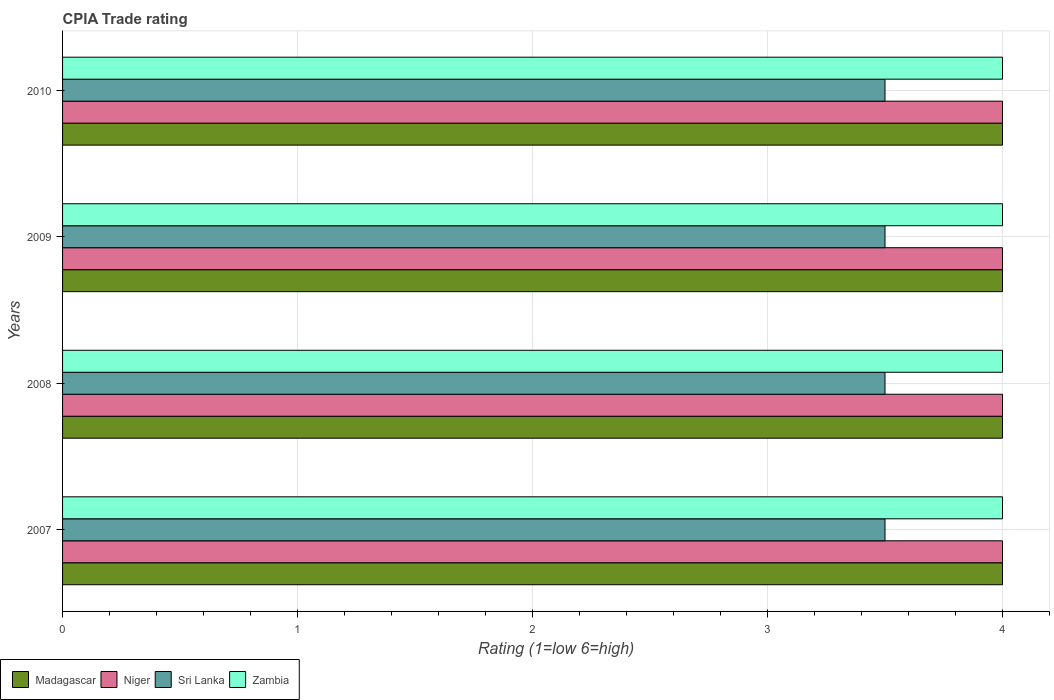What is the CPIA rating in Niger in 2008?
Provide a succinct answer. 4. Across all years, what is the maximum CPIA rating in Sri Lanka?
Make the answer very short. 3.5. In which year was the CPIA rating in Madagascar maximum?
Your response must be concise. 2007. What is the total CPIA rating in Zambia in the graph?
Ensure brevity in your answer.  16. In the year 2010, what is the difference between the CPIA rating in Niger and CPIA rating in Sri Lanka?
Make the answer very short. 0.5. What is the ratio of the CPIA rating in Madagascar in 2008 to that in 2010?
Provide a succinct answer. 1. Is the difference between the CPIA rating in Niger in 2008 and 2009 greater than the difference between the CPIA rating in Sri Lanka in 2008 and 2009?
Give a very brief answer. No. What is the difference between the highest and the second highest CPIA rating in Zambia?
Give a very brief answer. 0. What is the difference between the highest and the lowest CPIA rating in Madagascar?
Give a very brief answer. 0. What does the 2nd bar from the top in 2008 represents?
Provide a succinct answer. Sri Lanka. What does the 1st bar from the bottom in 2008 represents?
Your answer should be very brief. Madagascar. How many bars are there?
Your answer should be compact. 16. How many years are there in the graph?
Keep it short and to the point. 4. Does the graph contain any zero values?
Give a very brief answer. No. Where does the legend appear in the graph?
Make the answer very short. Bottom left. How many legend labels are there?
Your response must be concise. 4. How are the legend labels stacked?
Offer a terse response. Horizontal. What is the title of the graph?
Keep it short and to the point. CPIA Trade rating. Does "Cyprus" appear as one of the legend labels in the graph?
Provide a short and direct response. No. What is the label or title of the X-axis?
Keep it short and to the point. Rating (1=low 6=high). What is the Rating (1=low 6=high) of Niger in 2007?
Your answer should be compact. 4. What is the Rating (1=low 6=high) in Sri Lanka in 2007?
Provide a succinct answer. 3.5. What is the Rating (1=low 6=high) of Niger in 2008?
Your answer should be very brief. 4. What is the Rating (1=low 6=high) of Madagascar in 2009?
Keep it short and to the point. 4. What is the Rating (1=low 6=high) in Niger in 2009?
Make the answer very short. 4. What is the Rating (1=low 6=high) in Sri Lanka in 2009?
Give a very brief answer. 3.5. What is the Rating (1=low 6=high) in Zambia in 2009?
Ensure brevity in your answer.  4. What is the Rating (1=low 6=high) of Sri Lanka in 2010?
Make the answer very short. 3.5. Across all years, what is the maximum Rating (1=low 6=high) in Madagascar?
Offer a very short reply. 4. Across all years, what is the maximum Rating (1=low 6=high) of Niger?
Your answer should be compact. 4. Across all years, what is the minimum Rating (1=low 6=high) in Madagascar?
Make the answer very short. 4. Across all years, what is the minimum Rating (1=low 6=high) in Sri Lanka?
Give a very brief answer. 3.5. Across all years, what is the minimum Rating (1=low 6=high) in Zambia?
Your answer should be compact. 4. What is the total Rating (1=low 6=high) in Niger in the graph?
Provide a short and direct response. 16. What is the total Rating (1=low 6=high) of Zambia in the graph?
Keep it short and to the point. 16. What is the difference between the Rating (1=low 6=high) in Sri Lanka in 2007 and that in 2008?
Provide a short and direct response. 0. What is the difference between the Rating (1=low 6=high) of Zambia in 2007 and that in 2008?
Offer a very short reply. 0. What is the difference between the Rating (1=low 6=high) in Madagascar in 2007 and that in 2009?
Give a very brief answer. 0. What is the difference between the Rating (1=low 6=high) in Sri Lanka in 2007 and that in 2009?
Offer a very short reply. 0. What is the difference between the Rating (1=low 6=high) in Zambia in 2007 and that in 2009?
Offer a terse response. 0. What is the difference between the Rating (1=low 6=high) in Niger in 2007 and that in 2010?
Your response must be concise. 0. What is the difference between the Rating (1=low 6=high) in Madagascar in 2008 and that in 2009?
Provide a short and direct response. 0. What is the difference between the Rating (1=low 6=high) in Niger in 2008 and that in 2009?
Offer a very short reply. 0. What is the difference between the Rating (1=low 6=high) of Madagascar in 2008 and that in 2010?
Your answer should be very brief. 0. What is the difference between the Rating (1=low 6=high) of Zambia in 2008 and that in 2010?
Provide a short and direct response. 0. What is the difference between the Rating (1=low 6=high) in Madagascar in 2009 and that in 2010?
Offer a very short reply. 0. What is the difference between the Rating (1=low 6=high) in Niger in 2009 and that in 2010?
Your response must be concise. 0. What is the difference between the Rating (1=low 6=high) of Sri Lanka in 2009 and that in 2010?
Give a very brief answer. 0. What is the difference between the Rating (1=low 6=high) in Madagascar in 2007 and the Rating (1=low 6=high) in Sri Lanka in 2008?
Offer a terse response. 0.5. What is the difference between the Rating (1=low 6=high) in Niger in 2007 and the Rating (1=low 6=high) in Sri Lanka in 2008?
Your response must be concise. 0.5. What is the difference between the Rating (1=low 6=high) in Madagascar in 2007 and the Rating (1=low 6=high) in Sri Lanka in 2009?
Provide a short and direct response. 0.5. What is the difference between the Rating (1=low 6=high) of Madagascar in 2007 and the Rating (1=low 6=high) of Zambia in 2009?
Your answer should be very brief. 0. What is the difference between the Rating (1=low 6=high) in Niger in 2007 and the Rating (1=low 6=high) in Zambia in 2009?
Keep it short and to the point. 0. What is the difference between the Rating (1=low 6=high) in Madagascar in 2007 and the Rating (1=low 6=high) in Zambia in 2010?
Make the answer very short. 0. What is the difference between the Rating (1=low 6=high) in Sri Lanka in 2007 and the Rating (1=low 6=high) in Zambia in 2010?
Keep it short and to the point. -0.5. What is the difference between the Rating (1=low 6=high) in Madagascar in 2008 and the Rating (1=low 6=high) in Niger in 2009?
Keep it short and to the point. 0. What is the difference between the Rating (1=low 6=high) in Madagascar in 2008 and the Rating (1=low 6=high) in Niger in 2010?
Ensure brevity in your answer.  0. What is the difference between the Rating (1=low 6=high) of Niger in 2008 and the Rating (1=low 6=high) of Sri Lanka in 2010?
Your answer should be compact. 0.5. What is the difference between the Rating (1=low 6=high) in Niger in 2008 and the Rating (1=low 6=high) in Zambia in 2010?
Provide a succinct answer. 0. What is the difference between the Rating (1=low 6=high) of Sri Lanka in 2008 and the Rating (1=low 6=high) of Zambia in 2010?
Give a very brief answer. -0.5. What is the difference between the Rating (1=low 6=high) of Madagascar in 2009 and the Rating (1=low 6=high) of Sri Lanka in 2010?
Your response must be concise. 0.5. What is the difference between the Rating (1=low 6=high) of Madagascar in 2009 and the Rating (1=low 6=high) of Zambia in 2010?
Offer a very short reply. 0. What is the difference between the Rating (1=low 6=high) in Sri Lanka in 2009 and the Rating (1=low 6=high) in Zambia in 2010?
Your response must be concise. -0.5. What is the average Rating (1=low 6=high) in Madagascar per year?
Provide a short and direct response. 4. In the year 2007, what is the difference between the Rating (1=low 6=high) in Madagascar and Rating (1=low 6=high) in Niger?
Offer a very short reply. 0. In the year 2007, what is the difference between the Rating (1=low 6=high) in Madagascar and Rating (1=low 6=high) in Sri Lanka?
Keep it short and to the point. 0.5. In the year 2007, what is the difference between the Rating (1=low 6=high) in Niger and Rating (1=low 6=high) in Zambia?
Keep it short and to the point. 0. In the year 2008, what is the difference between the Rating (1=low 6=high) in Madagascar and Rating (1=low 6=high) in Niger?
Offer a terse response. 0. In the year 2008, what is the difference between the Rating (1=low 6=high) in Niger and Rating (1=low 6=high) in Sri Lanka?
Provide a short and direct response. 0.5. In the year 2008, what is the difference between the Rating (1=low 6=high) in Niger and Rating (1=low 6=high) in Zambia?
Give a very brief answer. 0. In the year 2008, what is the difference between the Rating (1=low 6=high) of Sri Lanka and Rating (1=low 6=high) of Zambia?
Your response must be concise. -0.5. In the year 2009, what is the difference between the Rating (1=low 6=high) of Madagascar and Rating (1=low 6=high) of Zambia?
Provide a short and direct response. 0. In the year 2009, what is the difference between the Rating (1=low 6=high) of Niger and Rating (1=low 6=high) of Zambia?
Your answer should be compact. 0. In the year 2009, what is the difference between the Rating (1=low 6=high) of Sri Lanka and Rating (1=low 6=high) of Zambia?
Provide a succinct answer. -0.5. In the year 2010, what is the difference between the Rating (1=low 6=high) of Madagascar and Rating (1=low 6=high) of Zambia?
Provide a succinct answer. 0. In the year 2010, what is the difference between the Rating (1=low 6=high) of Sri Lanka and Rating (1=low 6=high) of Zambia?
Your response must be concise. -0.5. What is the ratio of the Rating (1=low 6=high) of Madagascar in 2007 to that in 2008?
Keep it short and to the point. 1. What is the ratio of the Rating (1=low 6=high) of Niger in 2007 to that in 2008?
Keep it short and to the point. 1. What is the ratio of the Rating (1=low 6=high) of Zambia in 2007 to that in 2008?
Your response must be concise. 1. What is the ratio of the Rating (1=low 6=high) in Sri Lanka in 2007 to that in 2009?
Give a very brief answer. 1. What is the ratio of the Rating (1=low 6=high) of Zambia in 2007 to that in 2009?
Your answer should be very brief. 1. What is the ratio of the Rating (1=low 6=high) in Zambia in 2007 to that in 2010?
Offer a very short reply. 1. What is the ratio of the Rating (1=low 6=high) of Niger in 2008 to that in 2009?
Offer a terse response. 1. What is the ratio of the Rating (1=low 6=high) of Sri Lanka in 2008 to that in 2009?
Provide a succinct answer. 1. What is the ratio of the Rating (1=low 6=high) in Zambia in 2008 to that in 2009?
Give a very brief answer. 1. What is the ratio of the Rating (1=low 6=high) in Niger in 2008 to that in 2010?
Your answer should be very brief. 1. What is the ratio of the Rating (1=low 6=high) of Sri Lanka in 2008 to that in 2010?
Ensure brevity in your answer.  1. What is the ratio of the Rating (1=low 6=high) in Zambia in 2008 to that in 2010?
Give a very brief answer. 1. What is the difference between the highest and the second highest Rating (1=low 6=high) of Madagascar?
Make the answer very short. 0. What is the difference between the highest and the second highest Rating (1=low 6=high) of Niger?
Your response must be concise. 0. What is the difference between the highest and the second highest Rating (1=low 6=high) of Zambia?
Make the answer very short. 0. What is the difference between the highest and the lowest Rating (1=low 6=high) of Zambia?
Keep it short and to the point. 0. 